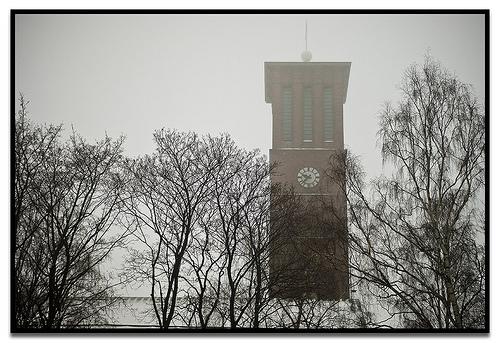Is the tower made of brick?
Keep it brief. Yes. What time is it?
Answer briefly. 7:50. Is it a sunny day?
Short answer required. No. 